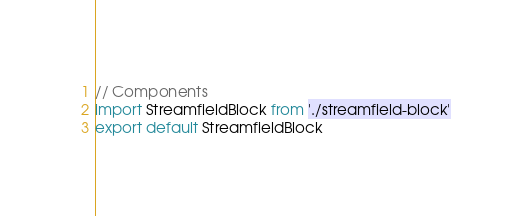Convert code to text. <code><loc_0><loc_0><loc_500><loc_500><_JavaScript_>// Components
import StreamfieldBlock from './streamfield-block'
export default StreamfieldBlock
</code> 